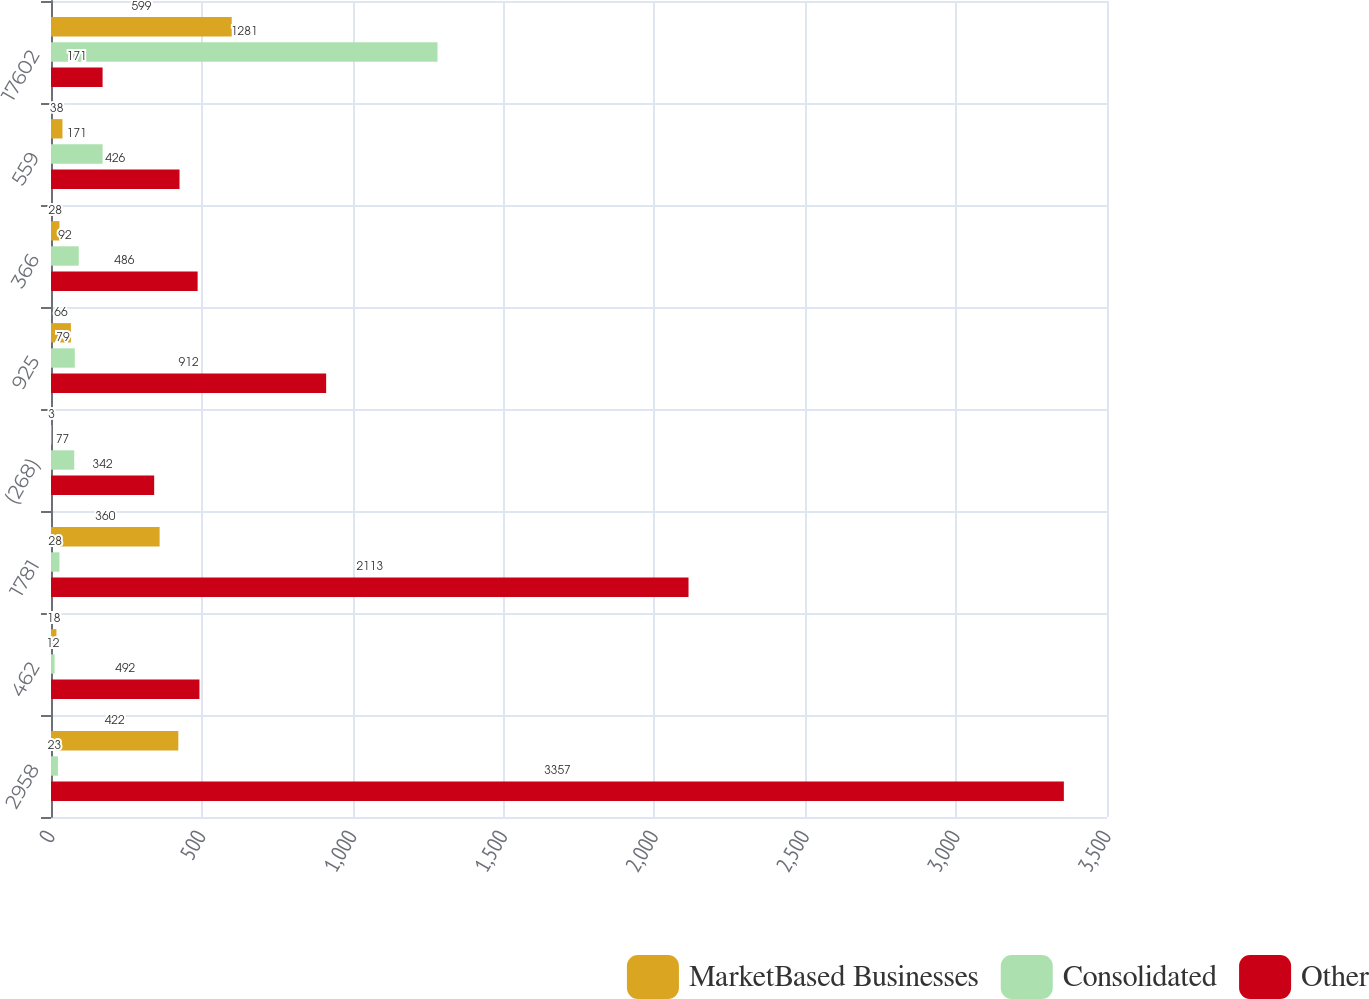Convert chart to OTSL. <chart><loc_0><loc_0><loc_500><loc_500><stacked_bar_chart><ecel><fcel>2958<fcel>462<fcel>1781<fcel>(268)<fcel>925<fcel>366<fcel>559<fcel>17602<nl><fcel>MarketBased Businesses<fcel>422<fcel>18<fcel>360<fcel>3<fcel>66<fcel>28<fcel>38<fcel>599<nl><fcel>Consolidated<fcel>23<fcel>12<fcel>28<fcel>77<fcel>79<fcel>92<fcel>171<fcel>1281<nl><fcel>Other<fcel>3357<fcel>492<fcel>2113<fcel>342<fcel>912<fcel>486<fcel>426<fcel>171<nl></chart> 